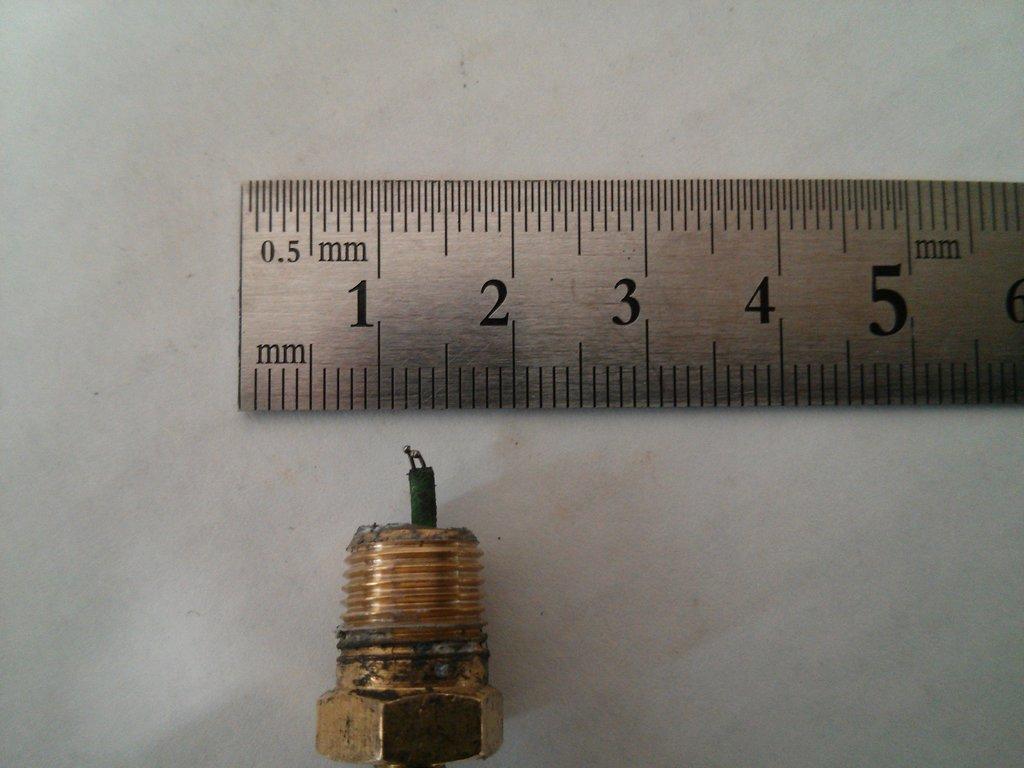What units are being used on the ruler?
Offer a very short reply. Mm. What is the lowest number on the ruler?
Your answer should be compact. 0.5. 